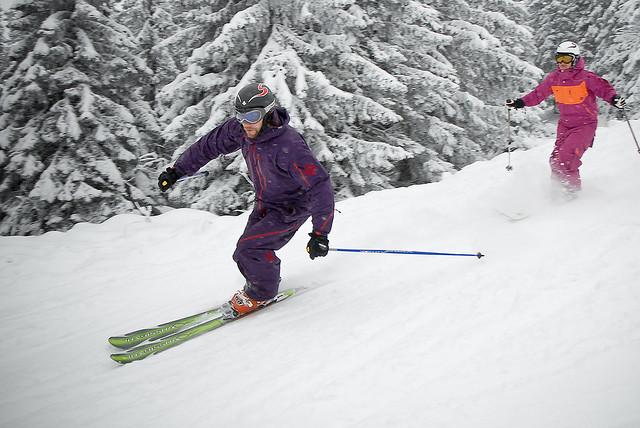Do the trees in this picture have snow on them?
Write a very short answer. Yes. How many skiers are in the picture?
Be succinct. 2. Is there enough snow for skiing?
Keep it brief. Yes. 